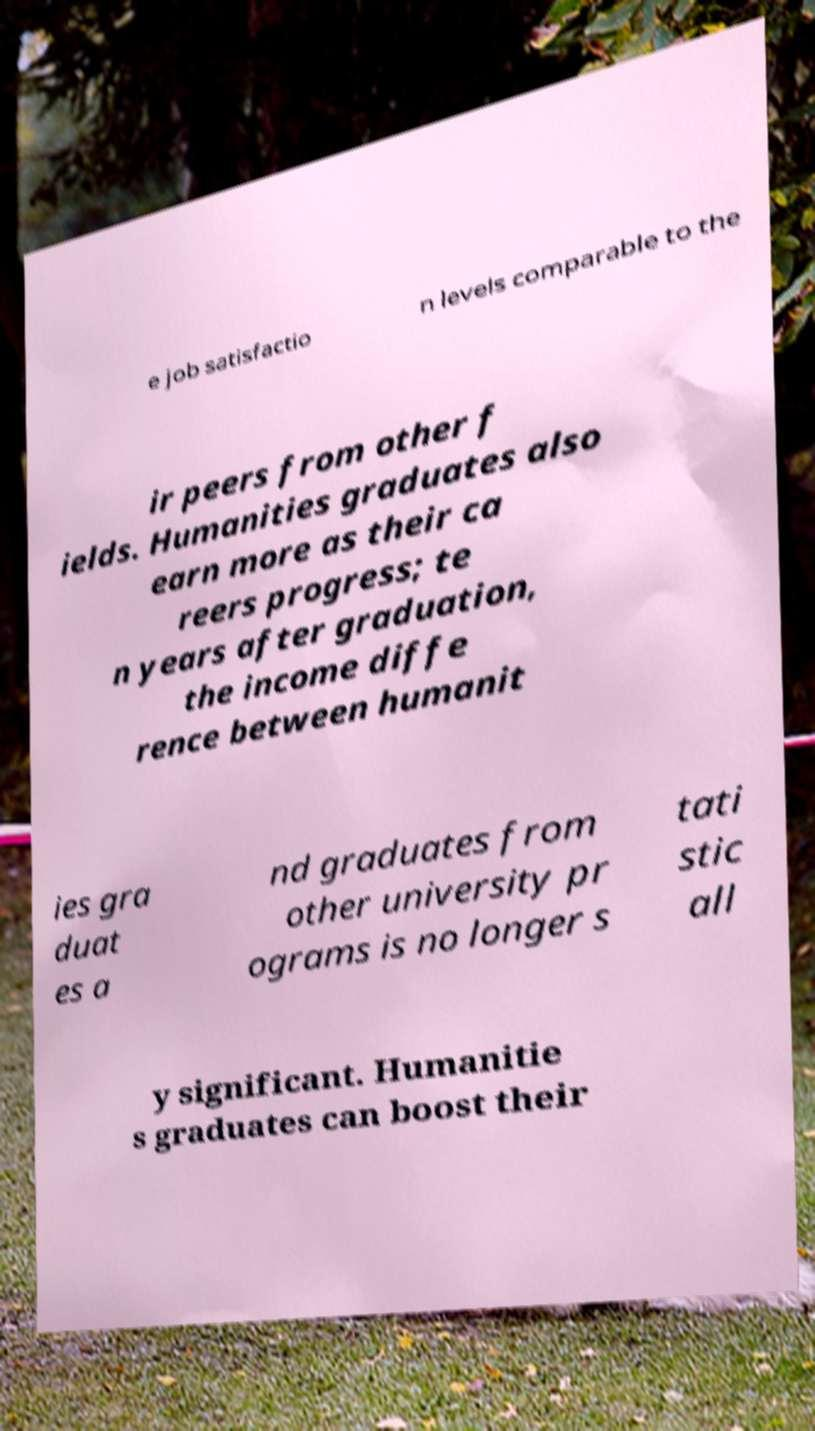There's text embedded in this image that I need extracted. Can you transcribe it verbatim? e job satisfactio n levels comparable to the ir peers from other f ields. Humanities graduates also earn more as their ca reers progress; te n years after graduation, the income diffe rence between humanit ies gra duat es a nd graduates from other university pr ograms is no longer s tati stic all y significant. Humanitie s graduates can boost their 